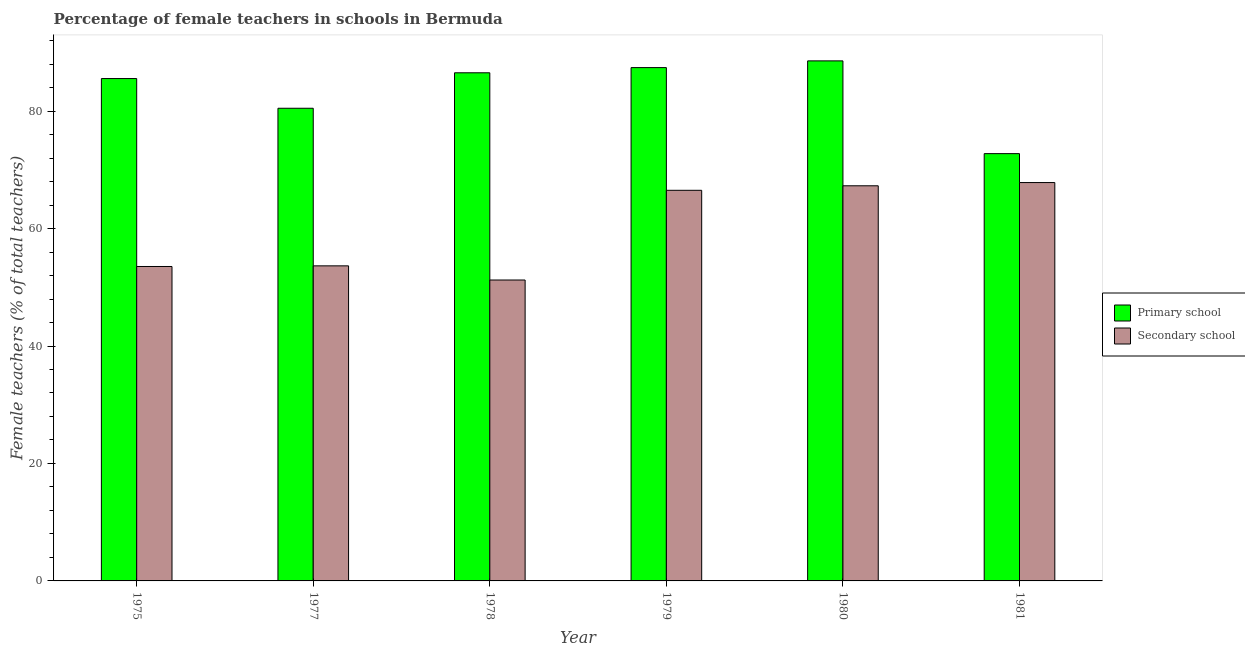Are the number of bars per tick equal to the number of legend labels?
Your answer should be compact. Yes. Are the number of bars on each tick of the X-axis equal?
Your answer should be compact. Yes. How many bars are there on the 1st tick from the right?
Your response must be concise. 2. What is the label of the 3rd group of bars from the left?
Offer a terse response. 1978. What is the percentage of female teachers in secondary schools in 1978?
Provide a short and direct response. 51.24. Across all years, what is the maximum percentage of female teachers in secondary schools?
Offer a very short reply. 67.83. Across all years, what is the minimum percentage of female teachers in secondary schools?
Ensure brevity in your answer.  51.24. In which year was the percentage of female teachers in primary schools maximum?
Your response must be concise. 1980. What is the total percentage of female teachers in secondary schools in the graph?
Make the answer very short. 360.05. What is the difference between the percentage of female teachers in primary schools in 1978 and that in 1980?
Keep it short and to the point. -2.03. What is the difference between the percentage of female teachers in primary schools in 1981 and the percentage of female teachers in secondary schools in 1980?
Your answer should be compact. -15.79. What is the average percentage of female teachers in secondary schools per year?
Your answer should be compact. 60.01. In the year 1977, what is the difference between the percentage of female teachers in secondary schools and percentage of female teachers in primary schools?
Keep it short and to the point. 0. In how many years, is the percentage of female teachers in primary schools greater than 12 %?
Your response must be concise. 6. What is the ratio of the percentage of female teachers in primary schools in 1977 to that in 1981?
Keep it short and to the point. 1.11. Is the percentage of female teachers in primary schools in 1975 less than that in 1981?
Offer a very short reply. No. Is the difference between the percentage of female teachers in secondary schools in 1979 and 1980 greater than the difference between the percentage of female teachers in primary schools in 1979 and 1980?
Offer a terse response. No. What is the difference between the highest and the second highest percentage of female teachers in secondary schools?
Your answer should be very brief. 0.55. What is the difference between the highest and the lowest percentage of female teachers in secondary schools?
Offer a very short reply. 16.59. In how many years, is the percentage of female teachers in primary schools greater than the average percentage of female teachers in primary schools taken over all years?
Your answer should be very brief. 4. Is the sum of the percentage of female teachers in secondary schools in 1975 and 1981 greater than the maximum percentage of female teachers in primary schools across all years?
Your answer should be compact. Yes. What does the 2nd bar from the left in 1981 represents?
Provide a succinct answer. Secondary school. What does the 1st bar from the right in 1979 represents?
Provide a succinct answer. Secondary school. How many bars are there?
Make the answer very short. 12. Are all the bars in the graph horizontal?
Your answer should be compact. No. How many years are there in the graph?
Your answer should be very brief. 6. What is the difference between two consecutive major ticks on the Y-axis?
Your answer should be compact. 20. Are the values on the major ticks of Y-axis written in scientific E-notation?
Keep it short and to the point. No. Does the graph contain any zero values?
Your answer should be very brief. No. Does the graph contain grids?
Offer a terse response. No. How many legend labels are there?
Your answer should be compact. 2. How are the legend labels stacked?
Provide a short and direct response. Vertical. What is the title of the graph?
Offer a very short reply. Percentage of female teachers in schools in Bermuda. What is the label or title of the X-axis?
Give a very brief answer. Year. What is the label or title of the Y-axis?
Provide a succinct answer. Female teachers (% of total teachers). What is the Female teachers (% of total teachers) in Primary school in 1975?
Your answer should be compact. 85.54. What is the Female teachers (% of total teachers) in Secondary school in 1975?
Your answer should be very brief. 53.54. What is the Female teachers (% of total teachers) in Primary school in 1977?
Make the answer very short. 80.48. What is the Female teachers (% of total teachers) in Secondary school in 1977?
Provide a succinct answer. 53.65. What is the Female teachers (% of total teachers) in Primary school in 1978?
Offer a terse response. 86.52. What is the Female teachers (% of total teachers) of Secondary school in 1978?
Ensure brevity in your answer.  51.24. What is the Female teachers (% of total teachers) in Primary school in 1979?
Keep it short and to the point. 87.4. What is the Female teachers (% of total teachers) of Secondary school in 1979?
Provide a succinct answer. 66.51. What is the Female teachers (% of total teachers) of Primary school in 1980?
Offer a very short reply. 88.55. What is the Female teachers (% of total teachers) in Secondary school in 1980?
Make the answer very short. 67.28. What is the Female teachers (% of total teachers) of Primary school in 1981?
Offer a very short reply. 72.76. What is the Female teachers (% of total teachers) of Secondary school in 1981?
Your answer should be compact. 67.83. Across all years, what is the maximum Female teachers (% of total teachers) in Primary school?
Your answer should be very brief. 88.55. Across all years, what is the maximum Female teachers (% of total teachers) of Secondary school?
Ensure brevity in your answer.  67.83. Across all years, what is the minimum Female teachers (% of total teachers) of Primary school?
Ensure brevity in your answer.  72.76. Across all years, what is the minimum Female teachers (% of total teachers) in Secondary school?
Ensure brevity in your answer.  51.24. What is the total Female teachers (% of total teachers) in Primary school in the graph?
Your response must be concise. 501.25. What is the total Female teachers (% of total teachers) of Secondary school in the graph?
Your response must be concise. 360.05. What is the difference between the Female teachers (% of total teachers) of Primary school in 1975 and that in 1977?
Offer a terse response. 5.06. What is the difference between the Female teachers (% of total teachers) in Secondary school in 1975 and that in 1977?
Offer a terse response. -0.11. What is the difference between the Female teachers (% of total teachers) of Primary school in 1975 and that in 1978?
Keep it short and to the point. -0.98. What is the difference between the Female teachers (% of total teachers) of Secondary school in 1975 and that in 1978?
Your response must be concise. 2.3. What is the difference between the Female teachers (% of total teachers) of Primary school in 1975 and that in 1979?
Make the answer very short. -1.87. What is the difference between the Female teachers (% of total teachers) of Secondary school in 1975 and that in 1979?
Ensure brevity in your answer.  -12.97. What is the difference between the Female teachers (% of total teachers) of Primary school in 1975 and that in 1980?
Make the answer very short. -3.01. What is the difference between the Female teachers (% of total teachers) of Secondary school in 1975 and that in 1980?
Ensure brevity in your answer.  -13.74. What is the difference between the Female teachers (% of total teachers) of Primary school in 1975 and that in 1981?
Offer a terse response. 12.78. What is the difference between the Female teachers (% of total teachers) in Secondary school in 1975 and that in 1981?
Give a very brief answer. -14.29. What is the difference between the Female teachers (% of total teachers) of Primary school in 1977 and that in 1978?
Your answer should be compact. -6.04. What is the difference between the Female teachers (% of total teachers) of Secondary school in 1977 and that in 1978?
Offer a terse response. 2.41. What is the difference between the Female teachers (% of total teachers) in Primary school in 1977 and that in 1979?
Provide a short and direct response. -6.92. What is the difference between the Female teachers (% of total teachers) of Secondary school in 1977 and that in 1979?
Offer a very short reply. -12.86. What is the difference between the Female teachers (% of total teachers) in Primary school in 1977 and that in 1980?
Keep it short and to the point. -8.07. What is the difference between the Female teachers (% of total teachers) in Secondary school in 1977 and that in 1980?
Keep it short and to the point. -13.63. What is the difference between the Female teachers (% of total teachers) in Primary school in 1977 and that in 1981?
Make the answer very short. 7.72. What is the difference between the Female teachers (% of total teachers) of Secondary school in 1977 and that in 1981?
Your answer should be compact. -14.18. What is the difference between the Female teachers (% of total teachers) of Primary school in 1978 and that in 1979?
Ensure brevity in your answer.  -0.88. What is the difference between the Female teachers (% of total teachers) in Secondary school in 1978 and that in 1979?
Give a very brief answer. -15.27. What is the difference between the Female teachers (% of total teachers) of Primary school in 1978 and that in 1980?
Keep it short and to the point. -2.03. What is the difference between the Female teachers (% of total teachers) in Secondary school in 1978 and that in 1980?
Your answer should be compact. -16.04. What is the difference between the Female teachers (% of total teachers) in Primary school in 1978 and that in 1981?
Your answer should be compact. 13.76. What is the difference between the Female teachers (% of total teachers) of Secondary school in 1978 and that in 1981?
Make the answer very short. -16.59. What is the difference between the Female teachers (% of total teachers) in Primary school in 1979 and that in 1980?
Make the answer very short. -1.15. What is the difference between the Female teachers (% of total teachers) in Secondary school in 1979 and that in 1980?
Your answer should be very brief. -0.77. What is the difference between the Female teachers (% of total teachers) of Primary school in 1979 and that in 1981?
Make the answer very short. 14.65. What is the difference between the Female teachers (% of total teachers) in Secondary school in 1979 and that in 1981?
Ensure brevity in your answer.  -1.32. What is the difference between the Female teachers (% of total teachers) of Primary school in 1980 and that in 1981?
Keep it short and to the point. 15.79. What is the difference between the Female teachers (% of total teachers) in Secondary school in 1980 and that in 1981?
Your response must be concise. -0.55. What is the difference between the Female teachers (% of total teachers) in Primary school in 1975 and the Female teachers (% of total teachers) in Secondary school in 1977?
Ensure brevity in your answer.  31.89. What is the difference between the Female teachers (% of total teachers) of Primary school in 1975 and the Female teachers (% of total teachers) of Secondary school in 1978?
Your answer should be compact. 34.3. What is the difference between the Female teachers (% of total teachers) in Primary school in 1975 and the Female teachers (% of total teachers) in Secondary school in 1979?
Offer a terse response. 19.03. What is the difference between the Female teachers (% of total teachers) of Primary school in 1975 and the Female teachers (% of total teachers) of Secondary school in 1980?
Make the answer very short. 18.26. What is the difference between the Female teachers (% of total teachers) of Primary school in 1975 and the Female teachers (% of total teachers) of Secondary school in 1981?
Your answer should be compact. 17.71. What is the difference between the Female teachers (% of total teachers) in Primary school in 1977 and the Female teachers (% of total teachers) in Secondary school in 1978?
Your response must be concise. 29.24. What is the difference between the Female teachers (% of total teachers) of Primary school in 1977 and the Female teachers (% of total teachers) of Secondary school in 1979?
Ensure brevity in your answer.  13.97. What is the difference between the Female teachers (% of total teachers) of Primary school in 1977 and the Female teachers (% of total teachers) of Secondary school in 1980?
Ensure brevity in your answer.  13.2. What is the difference between the Female teachers (% of total teachers) in Primary school in 1977 and the Female teachers (% of total teachers) in Secondary school in 1981?
Give a very brief answer. 12.65. What is the difference between the Female teachers (% of total teachers) in Primary school in 1978 and the Female teachers (% of total teachers) in Secondary school in 1979?
Your answer should be compact. 20.01. What is the difference between the Female teachers (% of total teachers) in Primary school in 1978 and the Female teachers (% of total teachers) in Secondary school in 1980?
Offer a very short reply. 19.24. What is the difference between the Female teachers (% of total teachers) of Primary school in 1978 and the Female teachers (% of total teachers) of Secondary school in 1981?
Offer a terse response. 18.69. What is the difference between the Female teachers (% of total teachers) in Primary school in 1979 and the Female teachers (% of total teachers) in Secondary school in 1980?
Make the answer very short. 20.12. What is the difference between the Female teachers (% of total teachers) in Primary school in 1979 and the Female teachers (% of total teachers) in Secondary school in 1981?
Provide a short and direct response. 19.57. What is the difference between the Female teachers (% of total teachers) in Primary school in 1980 and the Female teachers (% of total teachers) in Secondary school in 1981?
Make the answer very short. 20.72. What is the average Female teachers (% of total teachers) of Primary school per year?
Your answer should be compact. 83.54. What is the average Female teachers (% of total teachers) in Secondary school per year?
Provide a short and direct response. 60.01. In the year 1975, what is the difference between the Female teachers (% of total teachers) in Primary school and Female teachers (% of total teachers) in Secondary school?
Provide a succinct answer. 32. In the year 1977, what is the difference between the Female teachers (% of total teachers) in Primary school and Female teachers (% of total teachers) in Secondary school?
Your answer should be very brief. 26.83. In the year 1978, what is the difference between the Female teachers (% of total teachers) in Primary school and Female teachers (% of total teachers) in Secondary school?
Provide a succinct answer. 35.28. In the year 1979, what is the difference between the Female teachers (% of total teachers) in Primary school and Female teachers (% of total teachers) in Secondary school?
Your answer should be very brief. 20.89. In the year 1980, what is the difference between the Female teachers (% of total teachers) in Primary school and Female teachers (% of total teachers) in Secondary school?
Offer a terse response. 21.27. In the year 1981, what is the difference between the Female teachers (% of total teachers) of Primary school and Female teachers (% of total teachers) of Secondary school?
Make the answer very short. 4.93. What is the ratio of the Female teachers (% of total teachers) in Primary school in 1975 to that in 1977?
Provide a short and direct response. 1.06. What is the ratio of the Female teachers (% of total teachers) in Secondary school in 1975 to that in 1977?
Provide a short and direct response. 1. What is the ratio of the Female teachers (% of total teachers) in Primary school in 1975 to that in 1978?
Provide a succinct answer. 0.99. What is the ratio of the Female teachers (% of total teachers) of Secondary school in 1975 to that in 1978?
Offer a very short reply. 1.04. What is the ratio of the Female teachers (% of total teachers) in Primary school in 1975 to that in 1979?
Offer a terse response. 0.98. What is the ratio of the Female teachers (% of total teachers) in Secondary school in 1975 to that in 1979?
Provide a succinct answer. 0.8. What is the ratio of the Female teachers (% of total teachers) of Secondary school in 1975 to that in 1980?
Your answer should be compact. 0.8. What is the ratio of the Female teachers (% of total teachers) in Primary school in 1975 to that in 1981?
Keep it short and to the point. 1.18. What is the ratio of the Female teachers (% of total teachers) of Secondary school in 1975 to that in 1981?
Provide a short and direct response. 0.79. What is the ratio of the Female teachers (% of total teachers) of Primary school in 1977 to that in 1978?
Make the answer very short. 0.93. What is the ratio of the Female teachers (% of total teachers) in Secondary school in 1977 to that in 1978?
Ensure brevity in your answer.  1.05. What is the ratio of the Female teachers (% of total teachers) of Primary school in 1977 to that in 1979?
Provide a succinct answer. 0.92. What is the ratio of the Female teachers (% of total teachers) in Secondary school in 1977 to that in 1979?
Your response must be concise. 0.81. What is the ratio of the Female teachers (% of total teachers) in Primary school in 1977 to that in 1980?
Your answer should be very brief. 0.91. What is the ratio of the Female teachers (% of total teachers) in Secondary school in 1977 to that in 1980?
Offer a terse response. 0.8. What is the ratio of the Female teachers (% of total teachers) in Primary school in 1977 to that in 1981?
Your response must be concise. 1.11. What is the ratio of the Female teachers (% of total teachers) of Secondary school in 1977 to that in 1981?
Your response must be concise. 0.79. What is the ratio of the Female teachers (% of total teachers) of Secondary school in 1978 to that in 1979?
Your response must be concise. 0.77. What is the ratio of the Female teachers (% of total teachers) in Primary school in 1978 to that in 1980?
Provide a short and direct response. 0.98. What is the ratio of the Female teachers (% of total teachers) of Secondary school in 1978 to that in 1980?
Offer a terse response. 0.76. What is the ratio of the Female teachers (% of total teachers) of Primary school in 1978 to that in 1981?
Offer a terse response. 1.19. What is the ratio of the Female teachers (% of total teachers) of Secondary school in 1978 to that in 1981?
Make the answer very short. 0.76. What is the ratio of the Female teachers (% of total teachers) of Primary school in 1979 to that in 1980?
Provide a short and direct response. 0.99. What is the ratio of the Female teachers (% of total teachers) in Primary school in 1979 to that in 1981?
Your answer should be very brief. 1.2. What is the ratio of the Female teachers (% of total teachers) of Secondary school in 1979 to that in 1981?
Provide a short and direct response. 0.98. What is the ratio of the Female teachers (% of total teachers) of Primary school in 1980 to that in 1981?
Provide a succinct answer. 1.22. What is the ratio of the Female teachers (% of total teachers) of Secondary school in 1980 to that in 1981?
Provide a short and direct response. 0.99. What is the difference between the highest and the second highest Female teachers (% of total teachers) of Primary school?
Offer a terse response. 1.15. What is the difference between the highest and the second highest Female teachers (% of total teachers) in Secondary school?
Ensure brevity in your answer.  0.55. What is the difference between the highest and the lowest Female teachers (% of total teachers) of Primary school?
Offer a terse response. 15.79. What is the difference between the highest and the lowest Female teachers (% of total teachers) of Secondary school?
Provide a succinct answer. 16.59. 